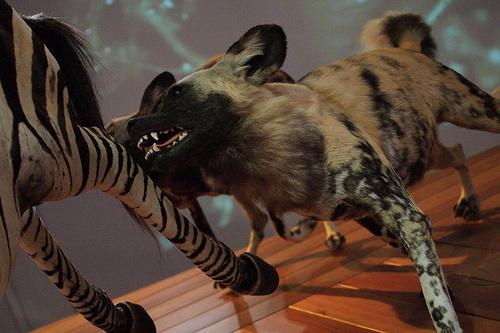What animal is chasing the zebra?
Keep it brief. Hyena. How many animals are shown?
Give a very brief answer. 3. Are these live animals?
Write a very short answer. No. 